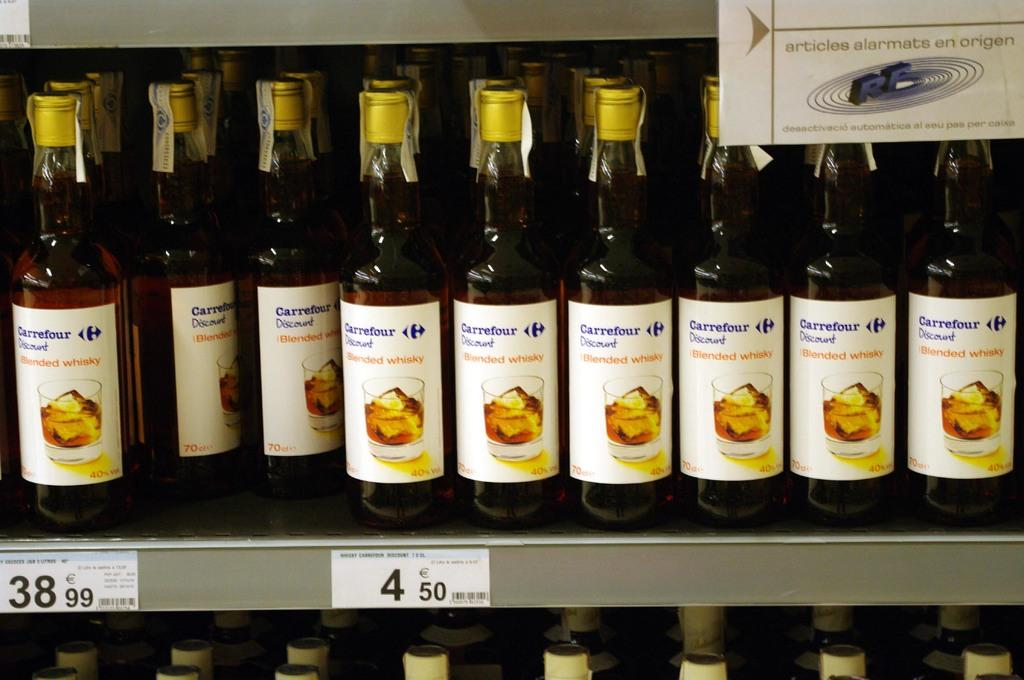<image>
Relay a brief, clear account of the picture shown. Many bottles of Carrefour blended whiskey are for sale in a store. 